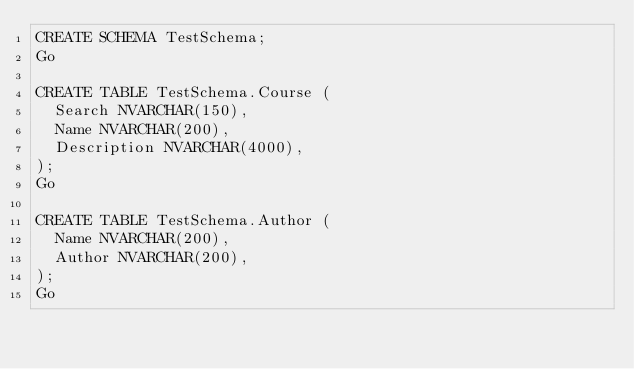<code> <loc_0><loc_0><loc_500><loc_500><_SQL_>CREATE SCHEMA TestSchema;
Go

CREATE TABLE TestSchema.Course (
  Search NVARCHAR(150),
  Name NVARCHAR(200),
  Description NVARCHAR(4000),
);
Go

CREATE TABLE TestSchema.Author (
  Name NVARCHAR(200),
  Author NVARCHAR(200),
);
Go</code> 